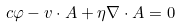Convert formula to latex. <formula><loc_0><loc_0><loc_500><loc_500>c \varphi - { v } \cdot { A } + \eta \nabla \cdot { A } = 0</formula> 